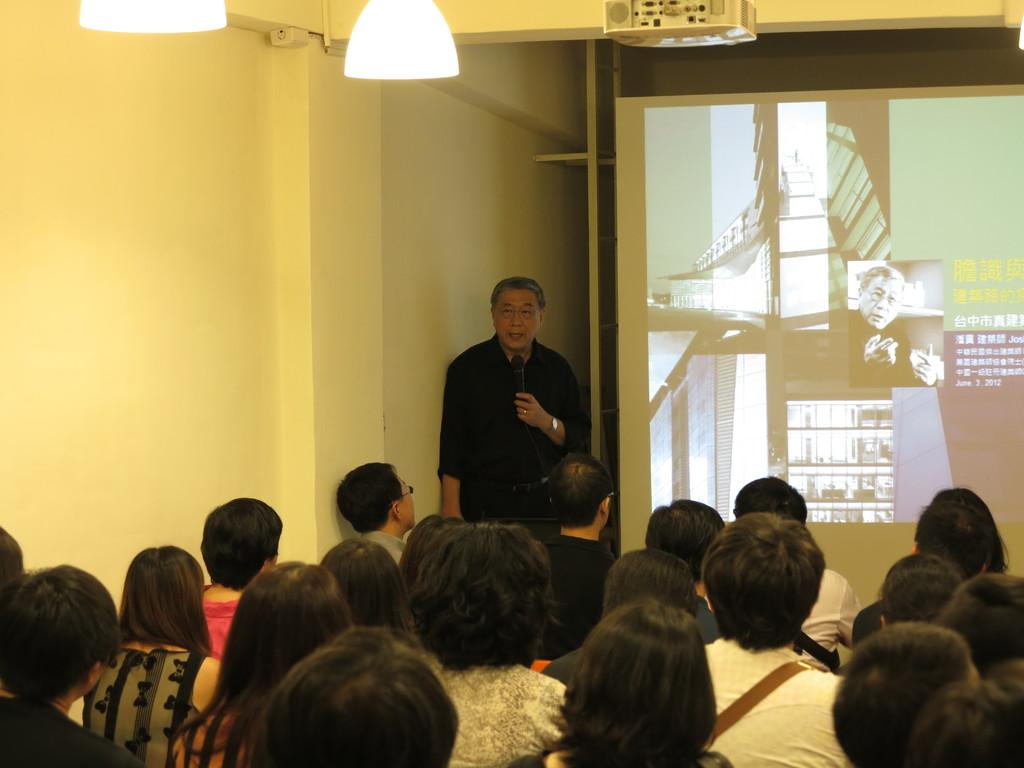What are the people in the image doing? The people in the image are sitting on chairs. What is in front of the people? There is a projector screen in front of the people. What is the person standing doing? The person standing is holding a microphone. How does the distribution of thunder change throughout the image? There is no mention of thunder in the image, so it cannot be determined how its distribution might change. 